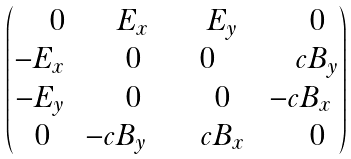Convert formula to latex. <formula><loc_0><loc_0><loc_500><loc_500>\begin{pmatrix} \quad \, 0 & \quad \, E _ { x } & \quad \, E _ { y } & \quad \, 0 \\ - E _ { x } & \quad \, 0 & \, 0 & \quad \, c B _ { y } \\ - E _ { y } & \quad \, 0 & \quad \, 0 & - c B _ { x } \\ \, 0 & - c B _ { y } & \quad \, c B _ { x } & \quad \, 0 \\ \end{pmatrix}</formula> 